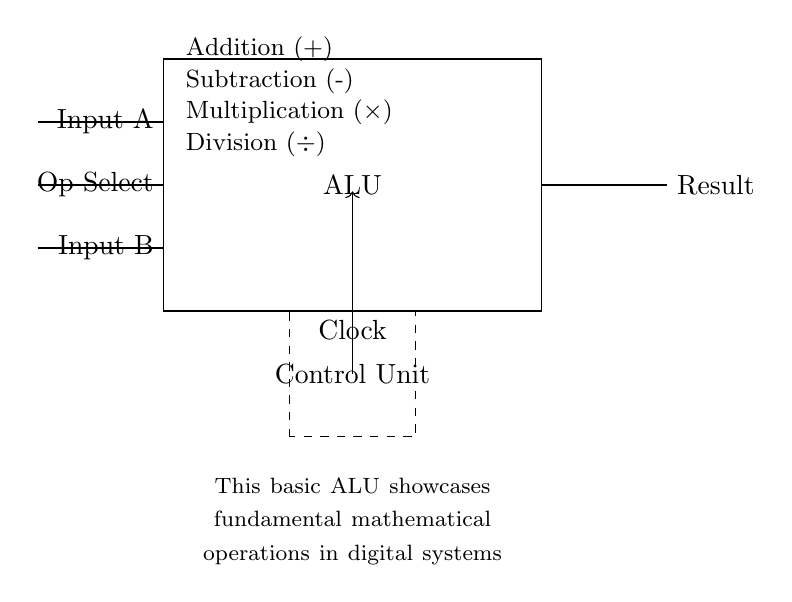What are the inputs for the ALU? The diagram shows two inputs labeled as "Input A" and "Input B". These are essential for performing operations in the ALU.
Answer: Input A and Input B How many basic operations are indicated in the ALU? From the diagram, four basic operations are labeled: Addition, Subtraction, Multiplication, and Division. These represent the mathematical functions that the ALU can perform.
Answer: Four What is the purpose of the Control Unit in the circuit? The Control Unit manages the selection of the operation to be performed by the ALU based on the "Op Select" input. It communicates with the ALU to execute the desired operation.
Answer: Manage operations How does the ALU indicate the operation it will perform? The operation is selected through the "Op Select" input, which informs the ALU of which mathematical operation to execute from the available four operations.
Answer: Op Select What role does the Clock signal play in this circuit? The Clock signal synchronizes the operations of the ALU, ensuring that all components operate in a coordinated fashion with consistent timing.
Answer: Synchronizes operations Which mathematical operation is at the top of the list in the circuit? The top operation listed in the ALU is Addition, as shown in the diagram where it is placed first among the four basic operations.
Answer: Addition 